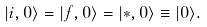Convert formula to latex. <formula><loc_0><loc_0><loc_500><loc_500>| i , 0 \rangle = | f , 0 \rangle = | * , 0 \rangle \equiv | 0 \rangle .</formula> 